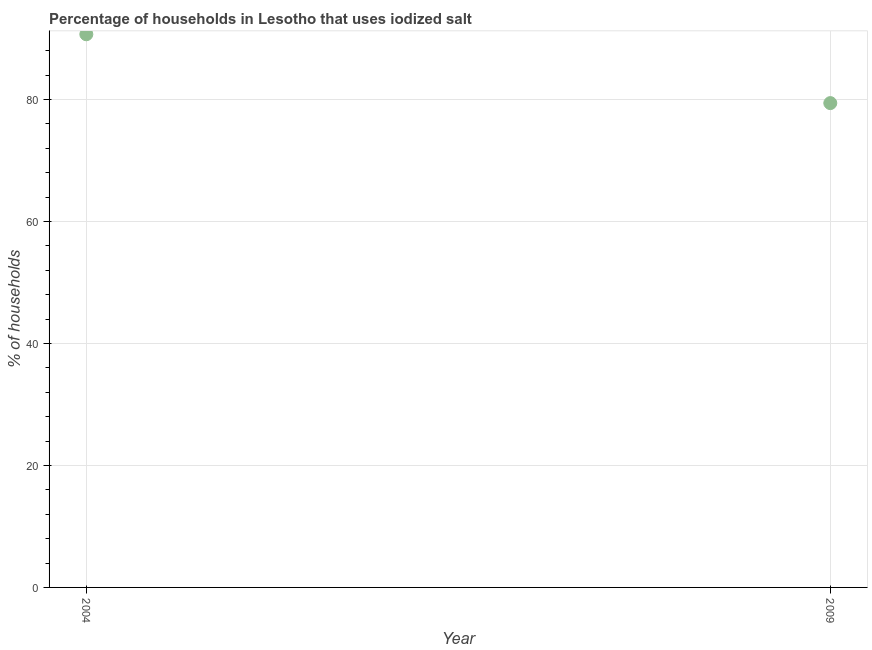What is the percentage of households where iodized salt is consumed in 2009?
Ensure brevity in your answer.  79.41. Across all years, what is the maximum percentage of households where iodized salt is consumed?
Offer a very short reply. 90.7. Across all years, what is the minimum percentage of households where iodized salt is consumed?
Make the answer very short. 79.41. In which year was the percentage of households where iodized salt is consumed minimum?
Give a very brief answer. 2009. What is the sum of the percentage of households where iodized salt is consumed?
Make the answer very short. 170.11. What is the difference between the percentage of households where iodized salt is consumed in 2004 and 2009?
Your response must be concise. 11.29. What is the average percentage of households where iodized salt is consumed per year?
Give a very brief answer. 85.06. What is the median percentage of households where iodized salt is consumed?
Your answer should be compact. 85.06. Do a majority of the years between 2009 and 2004 (inclusive) have percentage of households where iodized salt is consumed greater than 8 %?
Offer a terse response. No. What is the ratio of the percentage of households where iodized salt is consumed in 2004 to that in 2009?
Give a very brief answer. 1.14. In how many years, is the percentage of households where iodized salt is consumed greater than the average percentage of households where iodized salt is consumed taken over all years?
Your answer should be very brief. 1. How many dotlines are there?
Give a very brief answer. 1. What is the difference between two consecutive major ticks on the Y-axis?
Make the answer very short. 20. Are the values on the major ticks of Y-axis written in scientific E-notation?
Make the answer very short. No. Does the graph contain any zero values?
Make the answer very short. No. Does the graph contain grids?
Keep it short and to the point. Yes. What is the title of the graph?
Your answer should be very brief. Percentage of households in Lesotho that uses iodized salt. What is the label or title of the X-axis?
Make the answer very short. Year. What is the label or title of the Y-axis?
Offer a terse response. % of households. What is the % of households in 2004?
Your answer should be compact. 90.7. What is the % of households in 2009?
Keep it short and to the point. 79.41. What is the difference between the % of households in 2004 and 2009?
Offer a very short reply. 11.29. What is the ratio of the % of households in 2004 to that in 2009?
Ensure brevity in your answer.  1.14. 